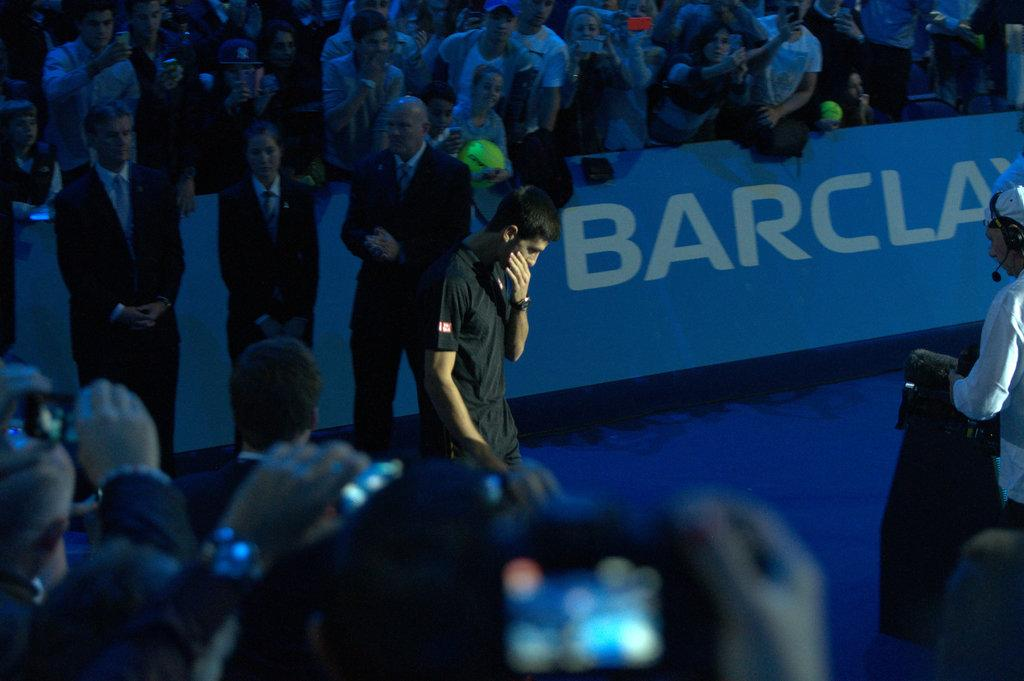How many people are visible in the image? There are many people standing in the image. What are the people wearing? The people are wearing clothes. Can you describe any accessories in the image? There is a wrist watch in the image. What is the purpose of the banner in the image? The purpose of the banner is not clear from the image, but it may be used for advertising or conveying information. What type of device is present in the image? There is a device in the image, but its specific type is not mentioned in the facts. What are the people using to communicate in the image? The people are using headsets in the image. What type of leather can be seen on the star in the image? There is no star or leather present in the image. 